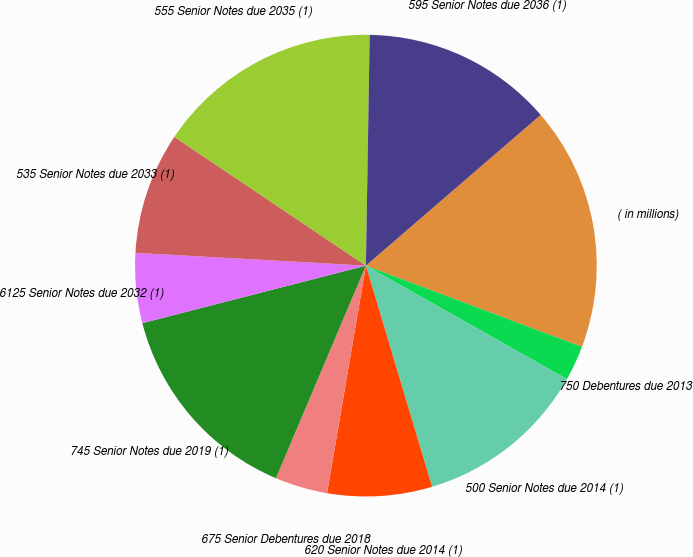<chart> <loc_0><loc_0><loc_500><loc_500><pie_chart><fcel>( in millions)<fcel>750 Debentures due 2013<fcel>500 Senior Notes due 2014 (1)<fcel>620 Senior Notes due 2014 (1)<fcel>675 Senior Debentures due 2018<fcel>745 Senior Notes due 2019 (1)<fcel>6125 Senior Notes due 2032 (1)<fcel>535 Senior Notes due 2033 (1)<fcel>555 Senior Notes due 2035 (1)<fcel>595 Senior Notes due 2036 (1)<nl><fcel>17.05%<fcel>2.46%<fcel>12.19%<fcel>7.32%<fcel>3.68%<fcel>14.62%<fcel>4.89%<fcel>8.54%<fcel>15.84%<fcel>13.41%<nl></chart> 